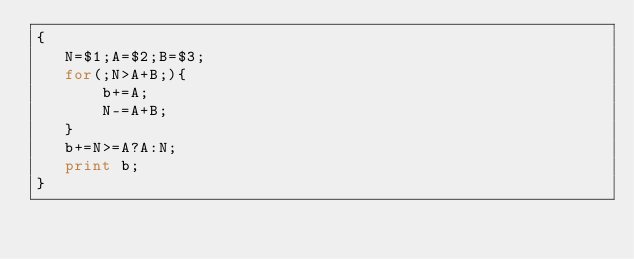<code> <loc_0><loc_0><loc_500><loc_500><_Awk_>{
   N=$1;A=$2;B=$3;
   for(;N>A+B;){
       b+=A;
       N-=A+B;
   }
   b+=N>=A?A:N;
   print b;
}</code> 